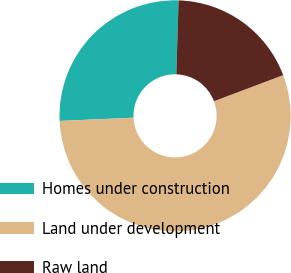Convert chart. <chart><loc_0><loc_0><loc_500><loc_500><pie_chart><fcel>Homes under construction<fcel>Land under development<fcel>Raw land<nl><fcel>26.19%<fcel>55.03%<fcel>18.78%<nl></chart> 